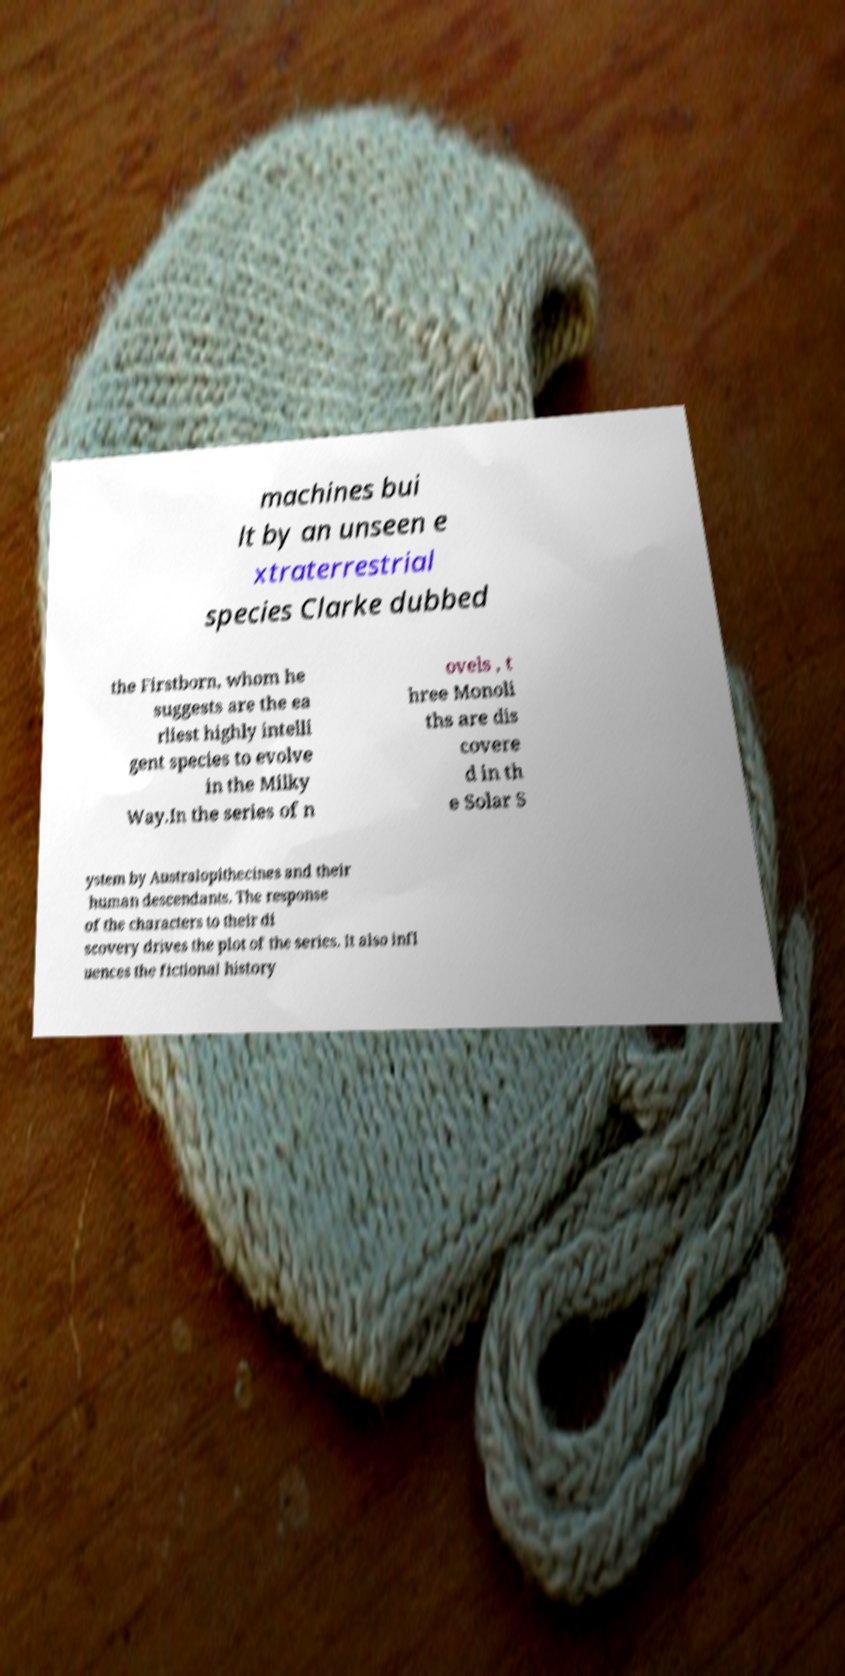For documentation purposes, I need the text within this image transcribed. Could you provide that? machines bui lt by an unseen e xtraterrestrial species Clarke dubbed the Firstborn, whom he suggests are the ea rliest highly intelli gent species to evolve in the Milky Way.In the series of n ovels , t hree Monoli ths are dis covere d in th e Solar S ystem by Australopithecines and their human descendants. The response of the characters to their di scovery drives the plot of the series. It also infl uences the fictional history 